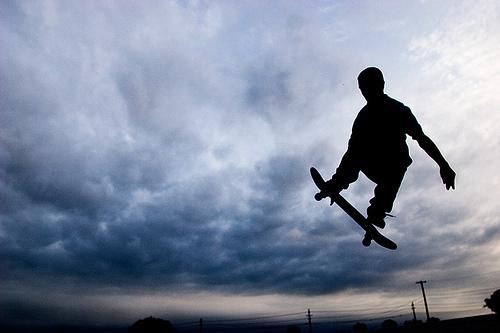Question: when is this photo taken?
Choices:
A. Evening.
B. Afternoon.
C. Dusk.
D. Nighttime.
Answer with the letter. Answer: C Question: what is the man riding?
Choices:
A. Rollerblades.
B. Bicycle.
C. Unicycle.
D. Skateboard.
Answer with the letter. Answer: D Question: who is the man in the photo?
Choices:
A. Rollerblader.
B. Bicycle rider.
C. Skateboarder.
D. Unicycle rider.
Answer with the letter. Answer: C Question: where is the man's left hand?
Choices:
A. Nex to his body.
B. On his left.
C. In the air.
D. Waving in the air.
Answer with the letter. Answer: C Question: what hand is the man touching the skateboard with?
Choices:
A. Not his left hand.
B. Right.
C. His predominant hand.
D. His writing hand.
Answer with the letter. Answer: B 